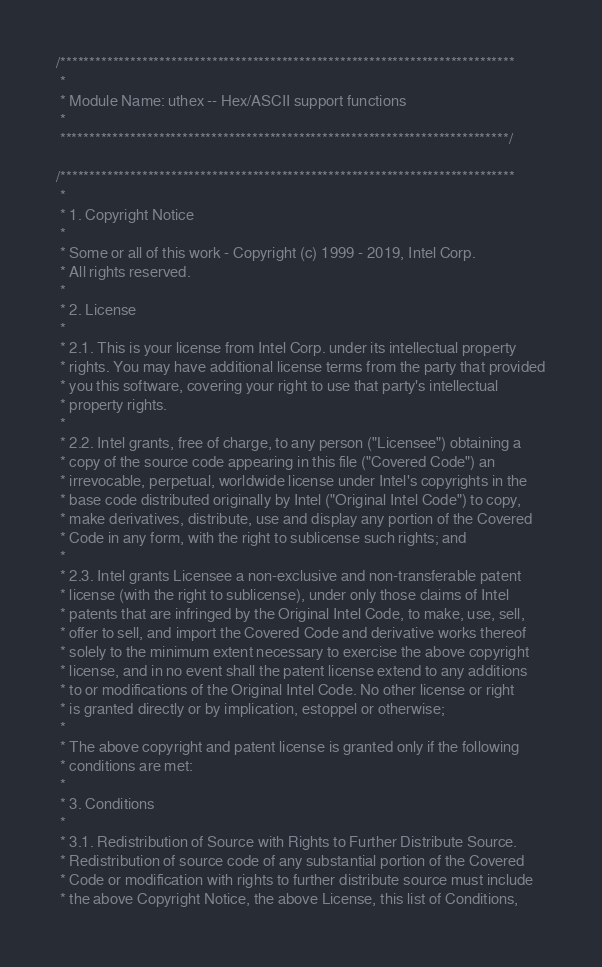<code> <loc_0><loc_0><loc_500><loc_500><_C_>/******************************************************************************
 *
 * Module Name: uthex -- Hex/ASCII support functions
 *
 *****************************************************************************/

/******************************************************************************
 *
 * 1. Copyright Notice
 *
 * Some or all of this work - Copyright (c) 1999 - 2019, Intel Corp.
 * All rights reserved.
 *
 * 2. License
 *
 * 2.1. This is your license from Intel Corp. under its intellectual property
 * rights. You may have additional license terms from the party that provided
 * you this software, covering your right to use that party's intellectual
 * property rights.
 *
 * 2.2. Intel grants, free of charge, to any person ("Licensee") obtaining a
 * copy of the source code appearing in this file ("Covered Code") an
 * irrevocable, perpetual, worldwide license under Intel's copyrights in the
 * base code distributed originally by Intel ("Original Intel Code") to copy,
 * make derivatives, distribute, use and display any portion of the Covered
 * Code in any form, with the right to sublicense such rights; and
 *
 * 2.3. Intel grants Licensee a non-exclusive and non-transferable patent
 * license (with the right to sublicense), under only those claims of Intel
 * patents that are infringed by the Original Intel Code, to make, use, sell,
 * offer to sell, and import the Covered Code and derivative works thereof
 * solely to the minimum extent necessary to exercise the above copyright
 * license, and in no event shall the patent license extend to any additions
 * to or modifications of the Original Intel Code. No other license or right
 * is granted directly or by implication, estoppel or otherwise;
 *
 * The above copyright and patent license is granted only if the following
 * conditions are met:
 *
 * 3. Conditions
 *
 * 3.1. Redistribution of Source with Rights to Further Distribute Source.
 * Redistribution of source code of any substantial portion of the Covered
 * Code or modification with rights to further distribute source must include
 * the above Copyright Notice, the above License, this list of Conditions,</code> 